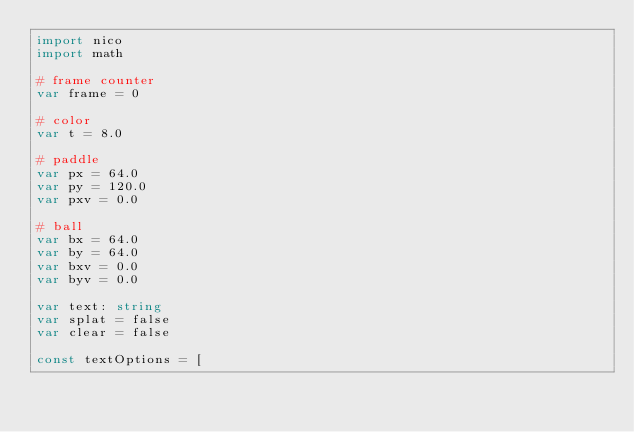Convert code to text. <code><loc_0><loc_0><loc_500><loc_500><_Nim_>import nico
import math

# frame counter
var frame = 0

# color
var t = 8.0

# paddle
var px = 64.0
var py = 120.0
var pxv = 0.0

# ball
var bx = 64.0
var by = 64.0
var bxv = 0.0
var byv = 0.0

var text: string
var splat = false
var clear = false

const textOptions = [</code> 